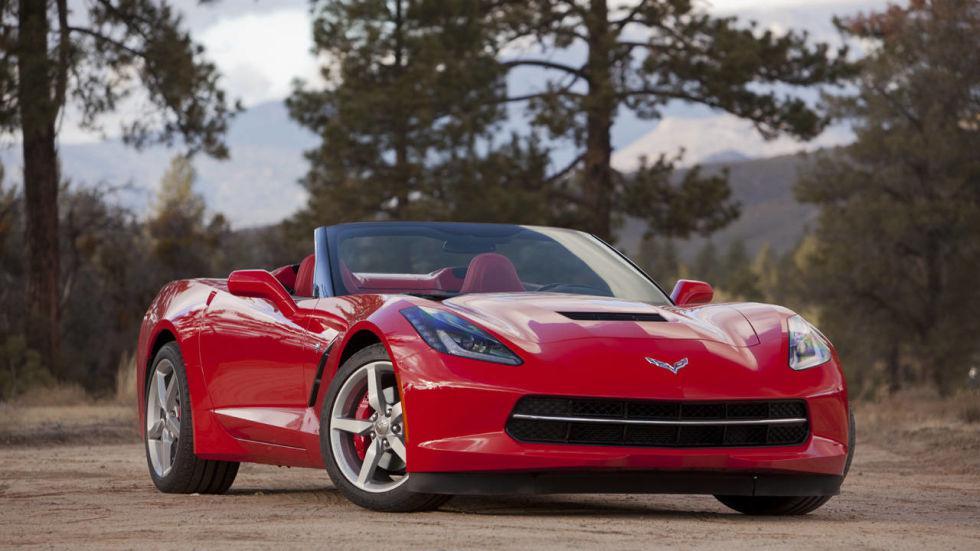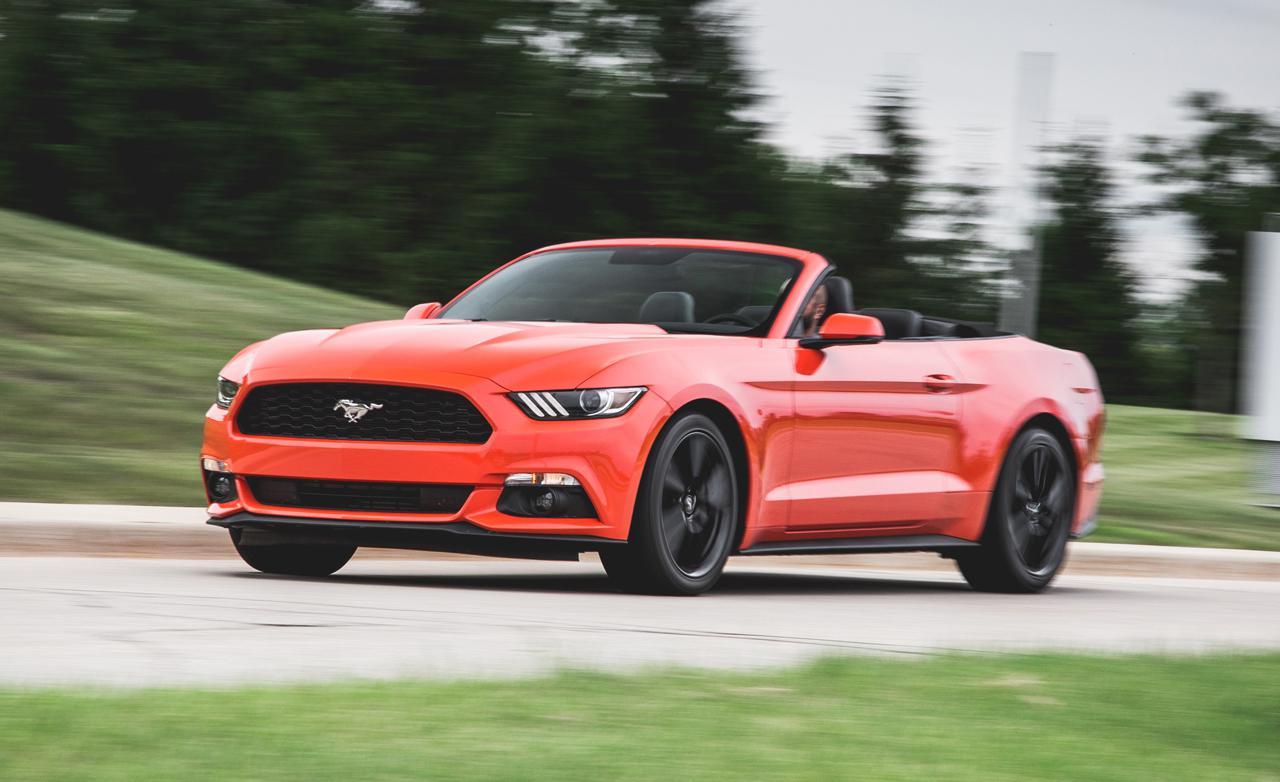The first image is the image on the left, the second image is the image on the right. For the images shown, is this caption "The left image features a red convertible car with its top down" true? Answer yes or no. Yes. The first image is the image on the left, the second image is the image on the right. Considering the images on both sides, is "The left image contains a red convertible vehicle." valid? Answer yes or no. Yes. 